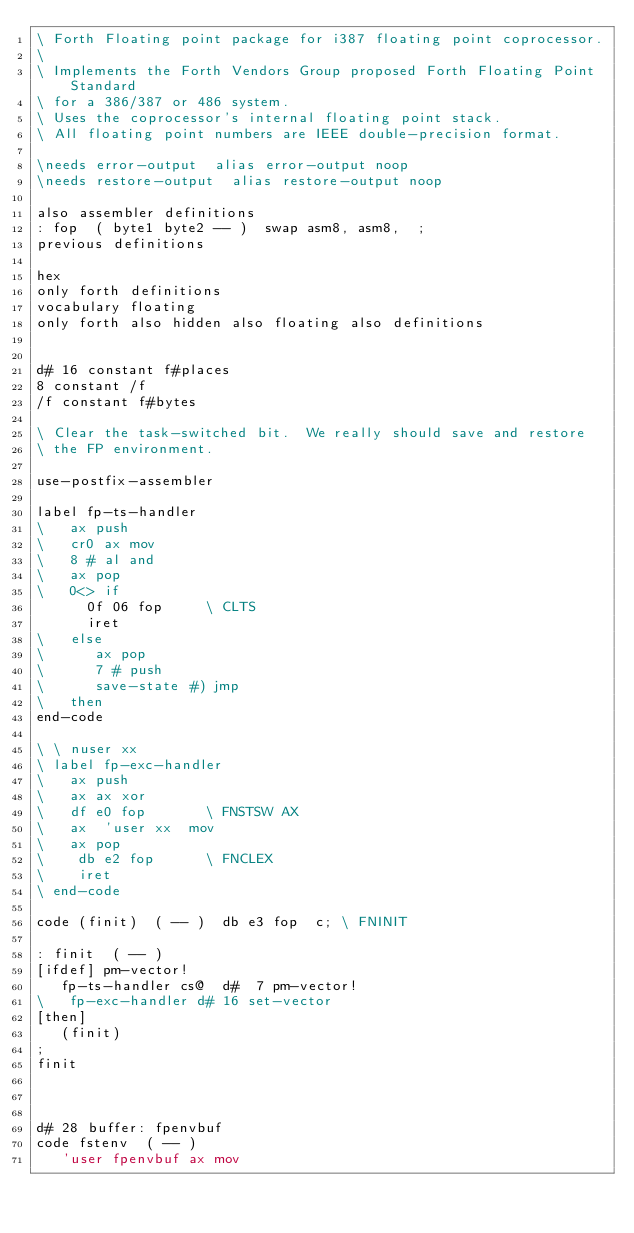Convert code to text. <code><loc_0><loc_0><loc_500><loc_500><_Forth_>\ Forth Floating point package for i387 floating point coprocessor.
\
\ Implements the Forth Vendors Group proposed Forth Floating Point Standard
\ for a 386/387 or 486 system.
\ Uses the coprocessor's internal floating point stack.
\ All floating point numbers are IEEE double-precision format.

\needs error-output  alias error-output noop
\needs restore-output  alias restore-output noop

also assembler definitions
: fop  ( byte1 byte2 -- )  swap asm8, asm8,  ;
previous definitions

hex
only forth definitions 
vocabulary floating
only forth also hidden also floating also definitions


d# 16 constant f#places
8 constant /f
/f constant f#bytes

\ Clear the task-switched bit.  We really should save and restore
\ the FP environment.

use-postfix-assembler

label fp-ts-handler
\   ax push
\   cr0 ax mov
\   8 # al and
\   ax pop
\   0<> if
      0f 06 fop		\ CLTS
      iret
\   else
\      ax pop
\      7 # push
\      save-state #) jmp
\   then
end-code

\ \ nuser xx
\ label fp-exc-handler
\   ax push
\   ax ax xor
\   df e0 fop		\ FNSTSW AX   
\   ax  'user xx  mov
\   ax pop
\    db e2 fop		\ FNCLEX
\    iret
\ end-code

code (finit)  ( -- )  db e3 fop  c;	\ FNINIT

: finit  ( -- )
[ifdef] pm-vector!
   fp-ts-handler cs@  d#  7 pm-vector!
\   fp-exc-handler d# 16 set-vector
[then]
   (finit)
;
finit



d# 28 buffer: fpenvbuf
code fstenv  ( -- )
   'user fpenvbuf ax mov</code> 